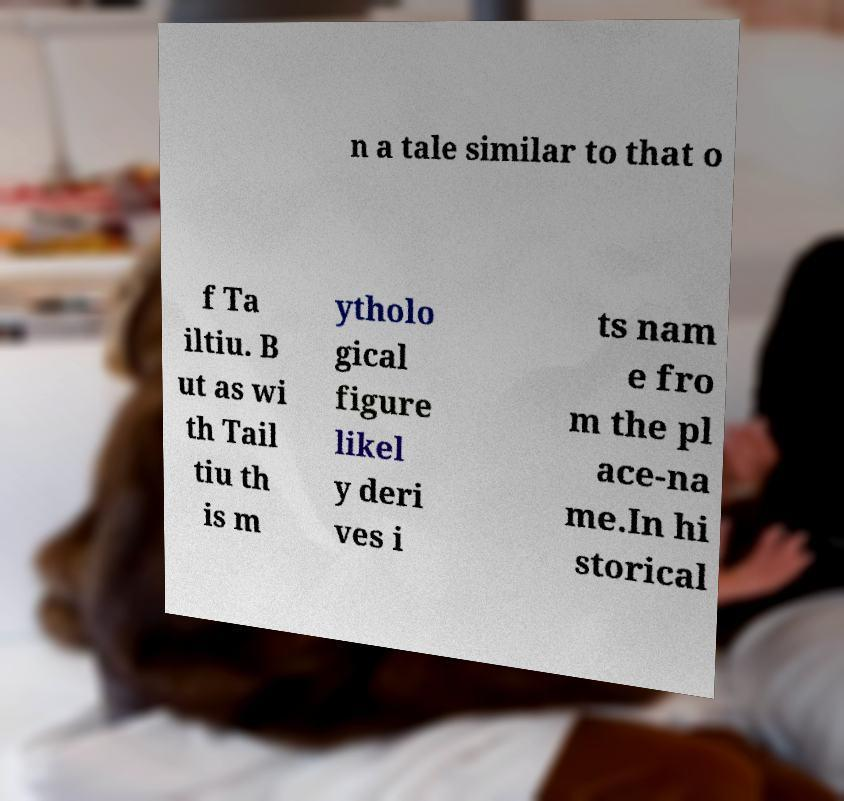Could you extract and type out the text from this image? n a tale similar to that o f Ta iltiu. B ut as wi th Tail tiu th is m ytholo gical figure likel y deri ves i ts nam e fro m the pl ace-na me.In hi storical 